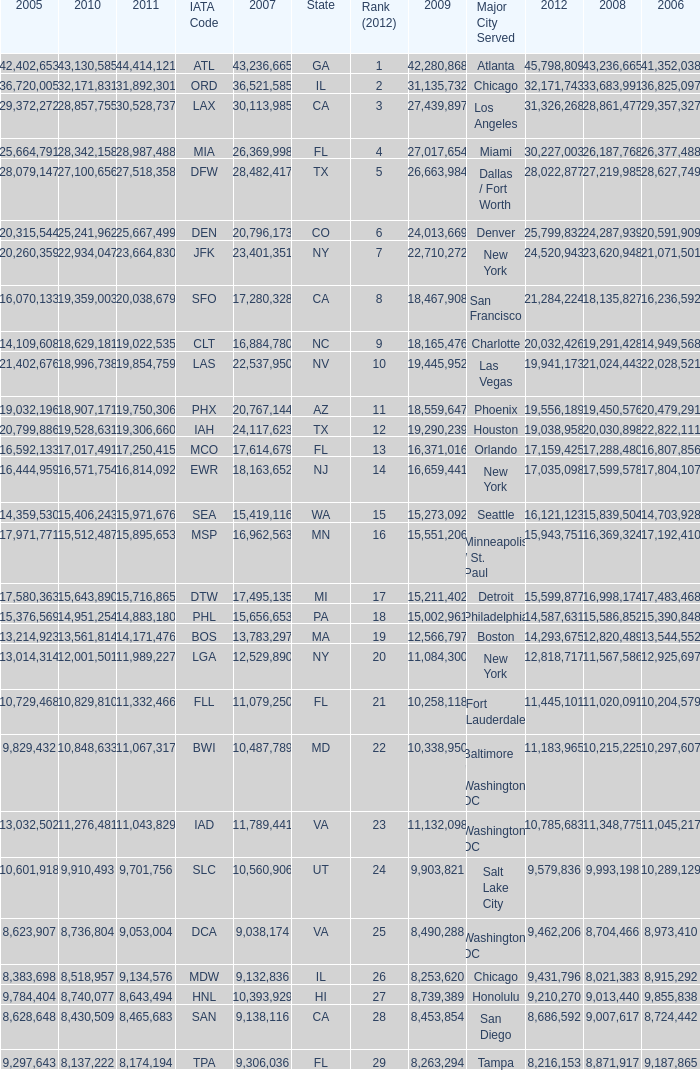When Philadelphia has a 2007 less than 20,796,173 and a 2008 more than 10,215,225, what is the smallest 2009? 15002961.0. 